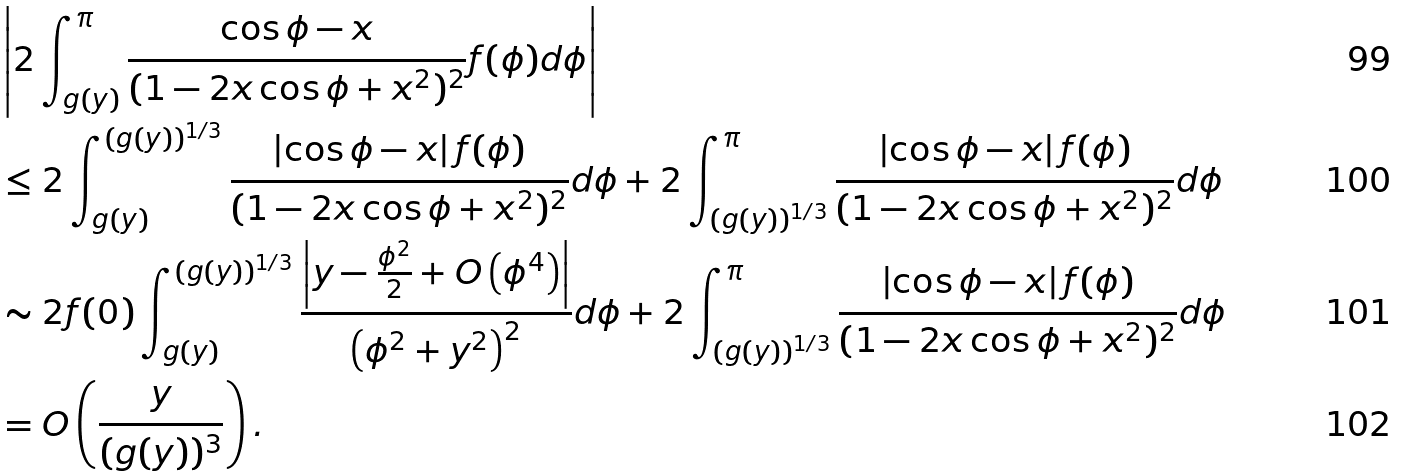Convert formula to latex. <formula><loc_0><loc_0><loc_500><loc_500>& \left | 2 \int _ { g ( y ) } ^ { \pi } \frac { \cos { \phi } - x } { ( 1 - 2 x \cos { \phi } + x ^ { 2 } ) ^ { 2 } } f ( \phi ) d \phi \right | \\ & \leq 2 \int _ { g ( y ) } ^ { ( g ( y ) ) ^ { 1 / 3 } } \frac { \left | \cos { \phi } - x \right | f ( \phi ) } { ( 1 - 2 x \cos { \phi } + x ^ { 2 } ) ^ { 2 } } d \phi + 2 \int _ { ( g ( y ) ) ^ { 1 / 3 } } ^ { \pi } \frac { \left | \cos { \phi } - x \right | f ( \phi ) } { ( 1 - 2 x \cos { \phi } + x ^ { 2 } ) ^ { 2 } } d \phi \\ & \sim 2 f ( 0 ) \int _ { g ( y ) } ^ { ( g ( y ) ) ^ { 1 / 3 } } \frac { \left | y - \frac { \phi ^ { 2 } } { 2 } + O \left ( \phi ^ { 4 } \right ) \right | } { \left ( \phi ^ { 2 } + y ^ { 2 } \right ) ^ { 2 } } d \phi + 2 \int _ { ( g ( y ) ) ^ { 1 / 3 } } ^ { \pi } \frac { \left | \cos { \phi } - x \right | f ( \phi ) } { ( 1 - 2 x \cos { \phi } + x ^ { 2 } ) ^ { 2 } } d \phi \\ & = O \left ( \frac { y } { ( g ( y ) ) ^ { 3 } } \right ) .</formula> 